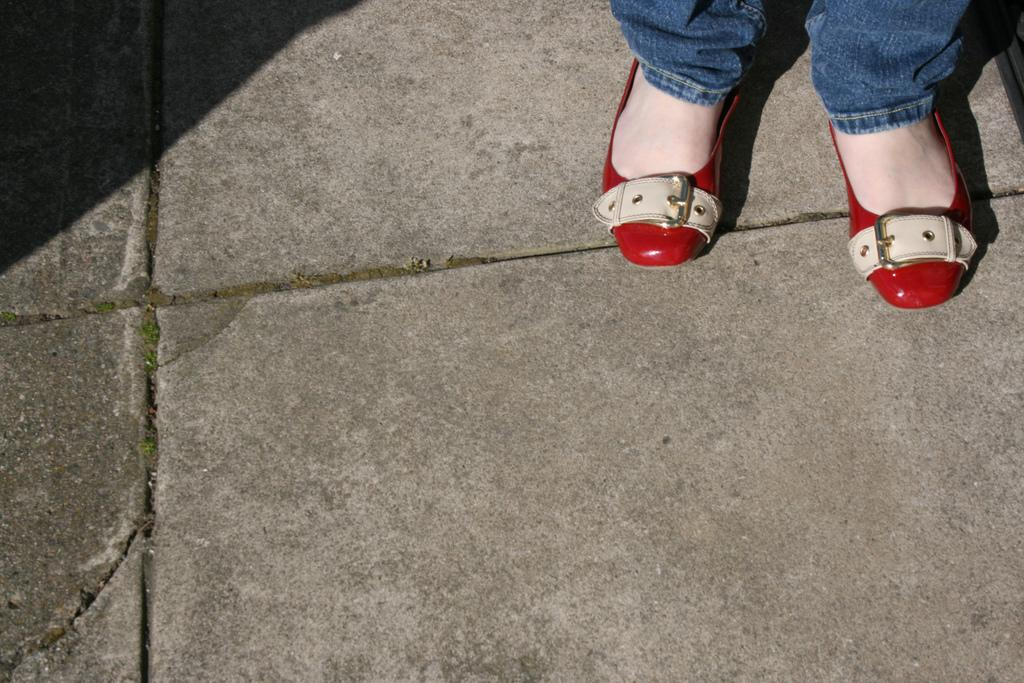What type of clothing is the person wearing on their legs? The person is wearing blue jeans. What type of footwear is the person wearing? The person is wearing red shoes. Where are the legs located in the image? The legs are on the floor. Can you describe the object on the top right side of the image? Unfortunately, the provided facts do not mention any object on the top right side of the image. What is the degree of existence of the force applied to the legs in the image? There is no mention of any force being applied to the legs in the image, so it is not possible to determine the degree of existence of such a force. 